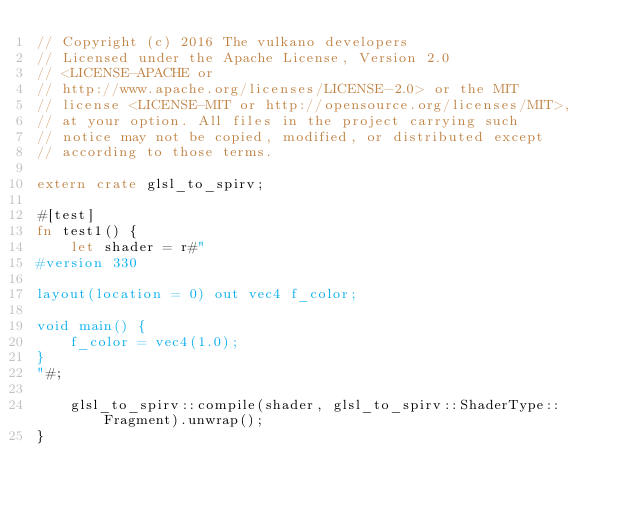Convert code to text. <code><loc_0><loc_0><loc_500><loc_500><_Rust_>// Copyright (c) 2016 The vulkano developers
// Licensed under the Apache License, Version 2.0
// <LICENSE-APACHE or
// http://www.apache.org/licenses/LICENSE-2.0> or the MIT
// license <LICENSE-MIT or http://opensource.org/licenses/MIT>,
// at your option. All files in the project carrying such
// notice may not be copied, modified, or distributed except
// according to those terms.

extern crate glsl_to_spirv;

#[test]
fn test1() {
    let shader = r#"
#version 330

layout(location = 0) out vec4 f_color;

void main() {
    f_color = vec4(1.0);
}
"#;

    glsl_to_spirv::compile(shader, glsl_to_spirv::ShaderType::Fragment).unwrap();
}
</code> 